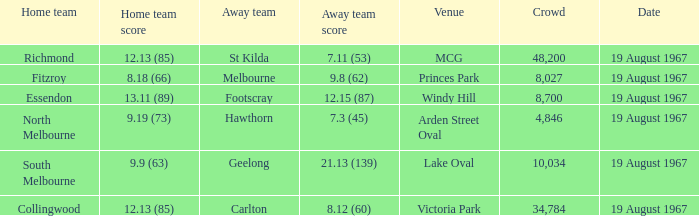When the away team scored 7.11 (53) what venue did they play at? MCG. 